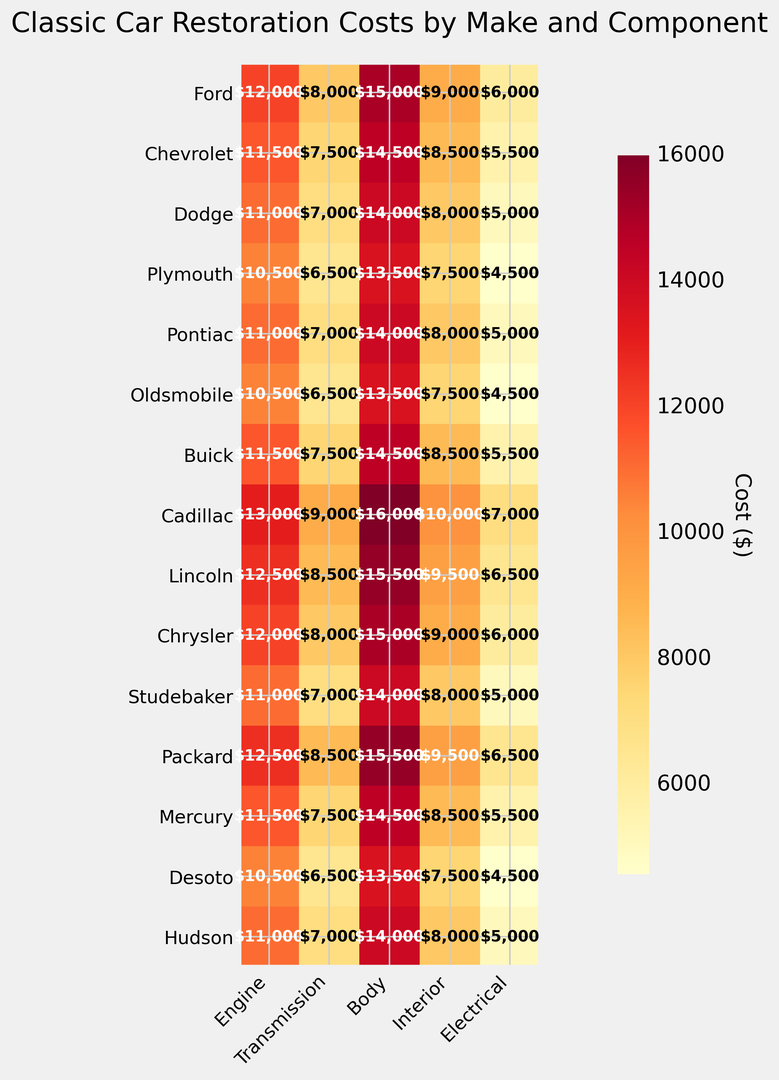Which make has the highest restoration cost for the engine? Look at the vertical axis for makes and the horizontal axis for the "Engine" component. The highest number corresponds to "Cadillac" with $13,000.
Answer: Cadillac Which car component has the lowest restoration cost across all makes? Compare all the costs across the rows and columns. The lowest number is $4,500 found under the "Electrical" component for "Plymouth", "Oldsmobile", and "Desoto".
Answer: Electrical What is the average restoration cost for the interior of all the classic cars? Sum the values in the "Interior" column and divide by the number of makes: (9000 + 8500 + 8000 + 7500 + 8000 + 7500 + 8500 + 10000 + 9500 + 9000 + 8000 + 9500 + 8500 + 7500 + 8000) / 15 = 8,333.33.
Answer: 8,333.33 Which make has the highest total restoration cost for all components combined? Sum the costs for all components per make and compare. Cadillac has the highest total: $53,000 (13,000 + 9,000 + 16,000 + 10,000 + 7,000).
Answer: Cadillac How does the cost of restoring a Ford’s body compare to a Chevrolet's body? Locate the "Body" column for both "Ford" and "Chevrolet". Ford has $15,000, and Chevrolet has $14,500. Ford's cost is higher.
Answer: Ford Which car has the most balanced (similar) restoration cost among its components? To determine this, check which car has the smallest difference between its highest and lowest component costs. By comparing visually, "Mercury" appears balanced with costs ranging from $5,500 to $14,500.
Answer: Mercury Which component shows the highest variation in restoration cost across different makes? Compare the ranges for each component by subtracting the minimum value from the maximum value in each column. "Body" shows the highest variation, from $13,500 to $16,000 (variation of $2,500).
Answer: Body Are there any makes where the electrical system restoration cost is greater than $6,000? Locate the "Electrical" column and find values greater than $6,000; "Cadillac", "Lincoln", and "Packard" fit this criterion.
Answer: Yes Which component for the Dodge make has the closest restoration cost to the average component restoration cost for all cars? Calculate the average for each component across all cars: Engine ~$11,300, Transmission ~$7,683, Body ~$14,333, Interior ~$8,333, Electrical ~$5,333. Dodge has values $11,000, $7,000, $14,000, $8,000, $5,000; the closest is the "Interior" with $8,000.
Answer: Interior Which make has the lowest restoration cost for the transmission component? Look at the "Transmission" column and find the lowest value, which is $6,500 seen in "Plymouth", "Oldsmobile", and "Desoto".
Answer: Plymouth, Oldsmobile, Desoto 